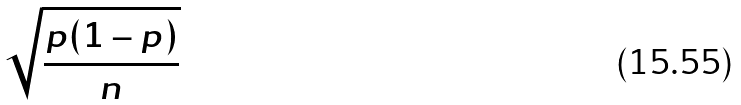Convert formula to latex. <formula><loc_0><loc_0><loc_500><loc_500>\sqrt { \frac { p ( 1 - p ) } { n } }</formula> 